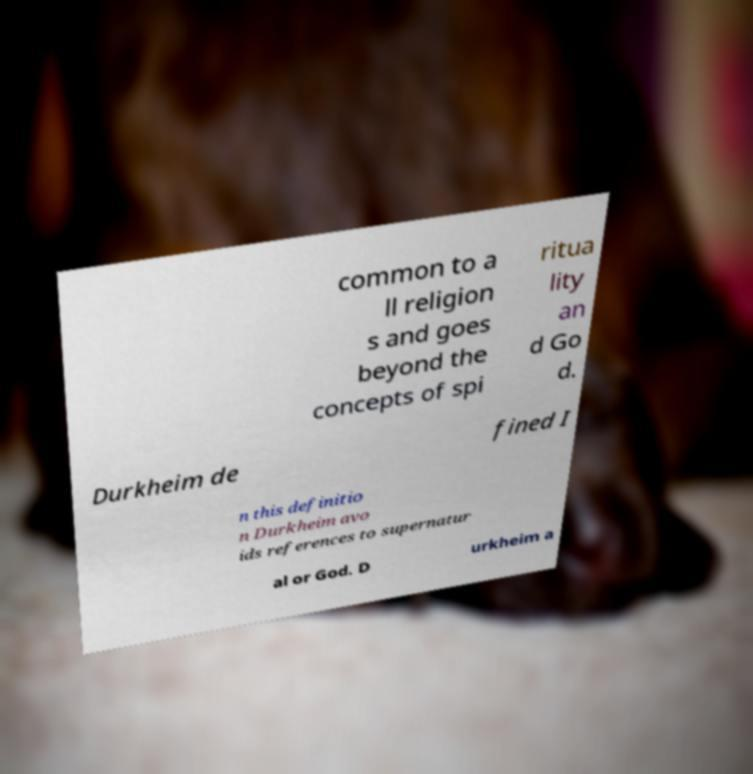Can you read and provide the text displayed in the image?This photo seems to have some interesting text. Can you extract and type it out for me? common to a ll religion s and goes beyond the concepts of spi ritua lity an d Go d. Durkheim de fined I n this definitio n Durkheim avo ids references to supernatur al or God. D urkheim a 